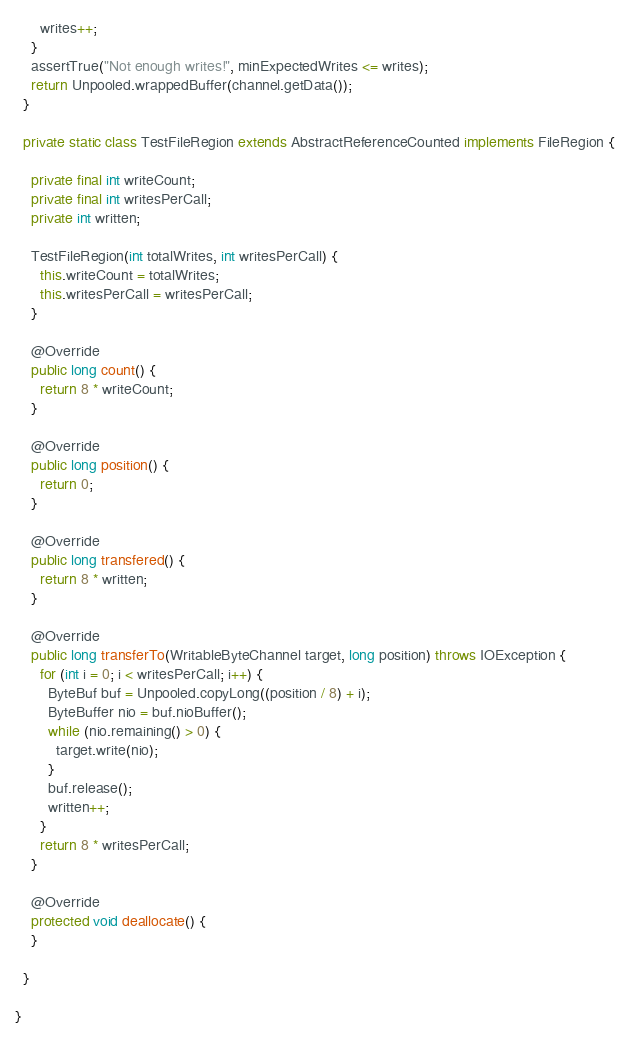<code> <loc_0><loc_0><loc_500><loc_500><_Java_>      writes++;
    }
    assertTrue("Not enough writes!", minExpectedWrites <= writes);
    return Unpooled.wrappedBuffer(channel.getData());
  }

  private static class TestFileRegion extends AbstractReferenceCounted implements FileRegion {

    private final int writeCount;
    private final int writesPerCall;
    private int written;

    TestFileRegion(int totalWrites, int writesPerCall) {
      this.writeCount = totalWrites;
      this.writesPerCall = writesPerCall;
    }

    @Override
    public long count() {
      return 8 * writeCount;
    }

    @Override
    public long position() {
      return 0;
    }

    @Override
    public long transfered() {
      return 8 * written;
    }

    @Override
    public long transferTo(WritableByteChannel target, long position) throws IOException {
      for (int i = 0; i < writesPerCall; i++) {
        ByteBuf buf = Unpooled.copyLong((position / 8) + i);
        ByteBuffer nio = buf.nioBuffer();
        while (nio.remaining() > 0) {
          target.write(nio);
        }
        buf.release();
        written++;
      }
      return 8 * writesPerCall;
    }

    @Override
    protected void deallocate() {
    }

  }

}
</code> 